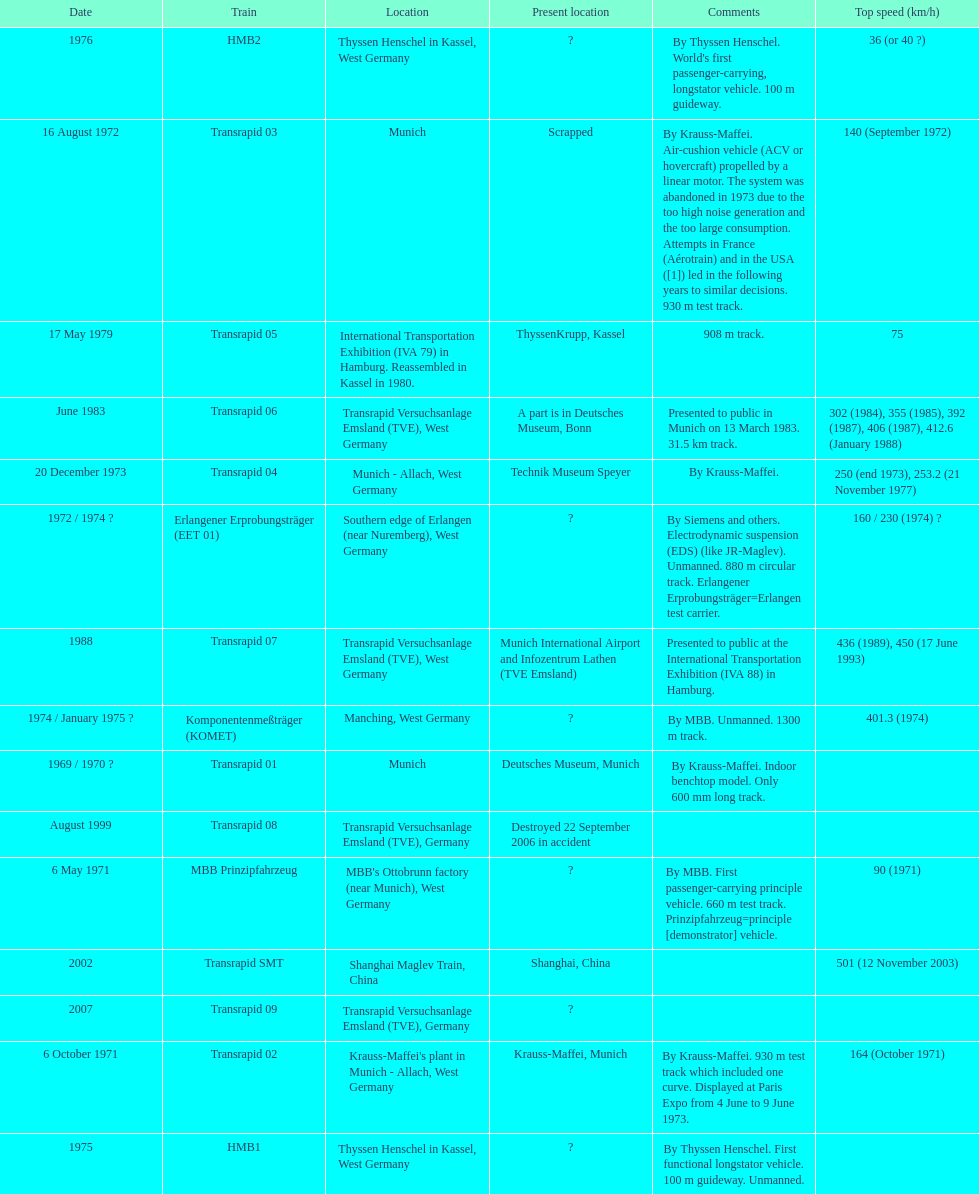What train was developed after the erlangener erprobungstrager? Transrapid 04. 